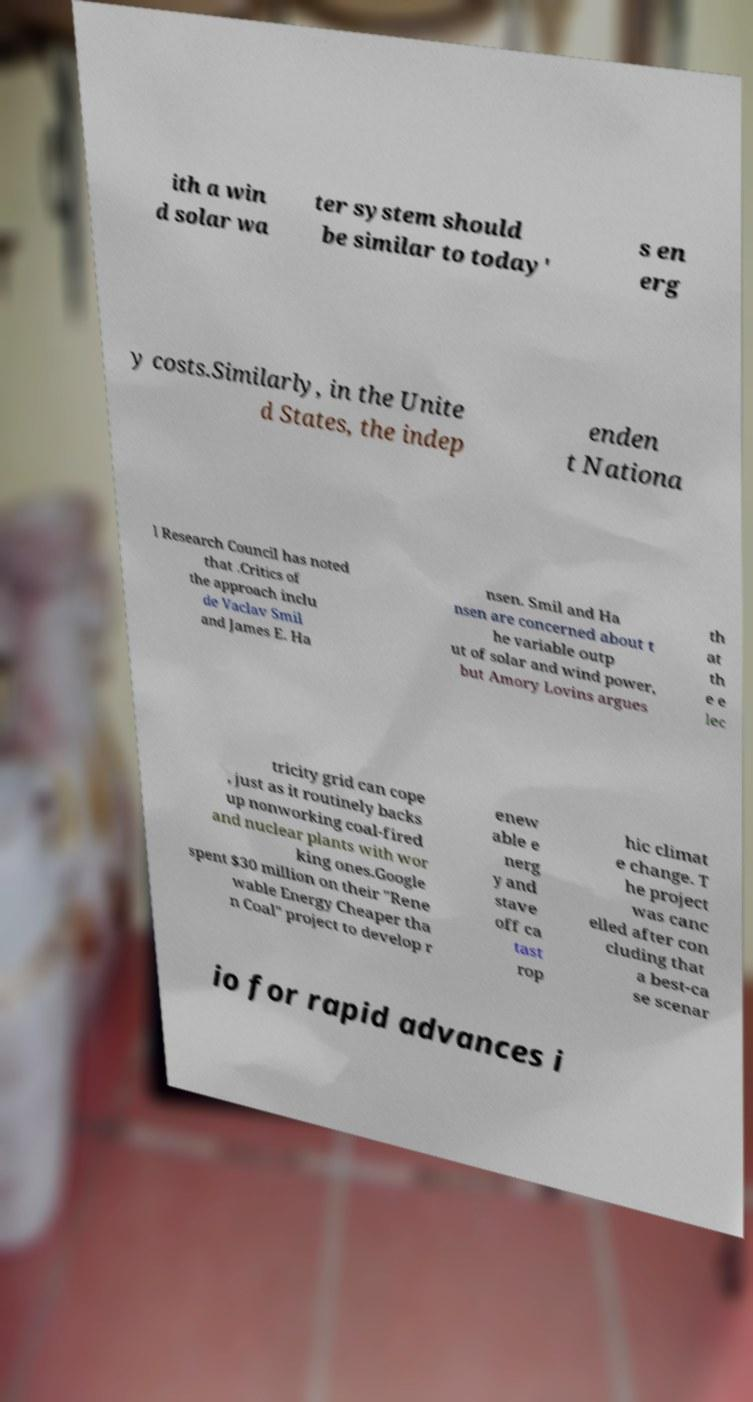Could you extract and type out the text from this image? ith a win d solar wa ter system should be similar to today' s en erg y costs.Similarly, in the Unite d States, the indep enden t Nationa l Research Council has noted that .Critics of the approach inclu de Vaclav Smil and James E. Ha nsen. Smil and Ha nsen are concerned about t he variable outp ut of solar and wind power, but Amory Lovins argues th at th e e lec tricity grid can cope , just as it routinely backs up nonworking coal-fired and nuclear plants with wor king ones.Google spent $30 million on their "Rene wable Energy Cheaper tha n Coal" project to develop r enew able e nerg y and stave off ca tast rop hic climat e change. T he project was canc elled after con cluding that a best-ca se scenar io for rapid advances i 